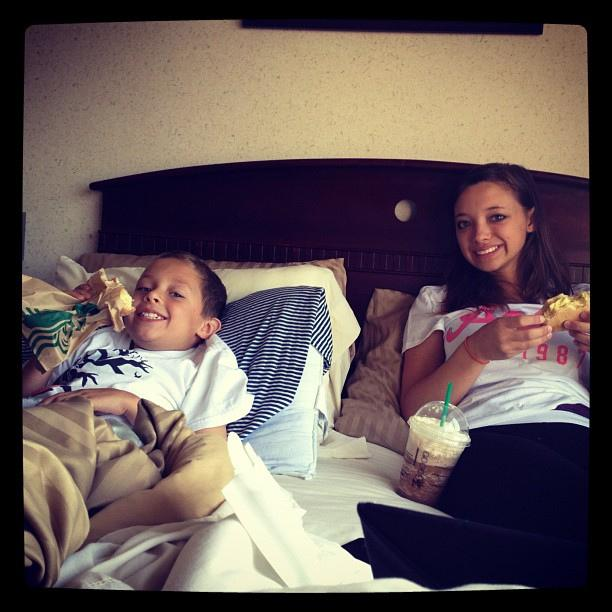What food place did the children get their food from?

Choices:
A) wendys
B) starbucks
C) mcdonalds
D) dunkin donuts starbucks 